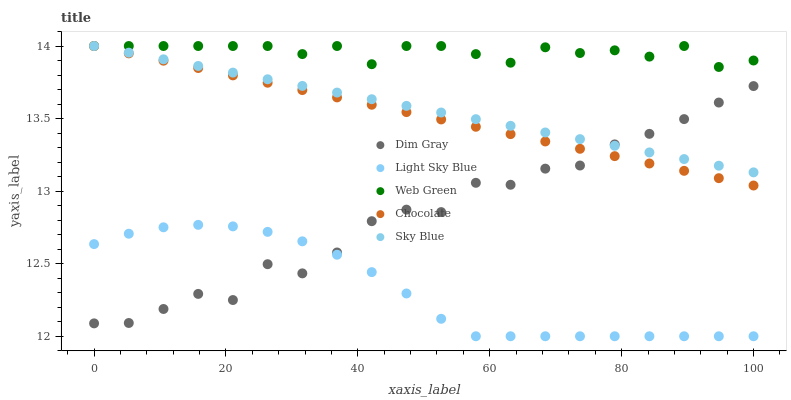Does Light Sky Blue have the minimum area under the curve?
Answer yes or no. Yes. Does Web Green have the maximum area under the curve?
Answer yes or no. Yes. Does Dim Gray have the minimum area under the curve?
Answer yes or no. No. Does Dim Gray have the maximum area under the curve?
Answer yes or no. No. Is Chocolate the smoothest?
Answer yes or no. Yes. Is Dim Gray the roughest?
Answer yes or no. Yes. Is Web Green the smoothest?
Answer yes or no. No. Is Web Green the roughest?
Answer yes or no. No. Does Light Sky Blue have the lowest value?
Answer yes or no. Yes. Does Dim Gray have the lowest value?
Answer yes or no. No. Does Chocolate have the highest value?
Answer yes or no. Yes. Does Dim Gray have the highest value?
Answer yes or no. No. Is Light Sky Blue less than Web Green?
Answer yes or no. Yes. Is Web Green greater than Dim Gray?
Answer yes or no. Yes. Does Chocolate intersect Sky Blue?
Answer yes or no. Yes. Is Chocolate less than Sky Blue?
Answer yes or no. No. Is Chocolate greater than Sky Blue?
Answer yes or no. No. Does Light Sky Blue intersect Web Green?
Answer yes or no. No. 